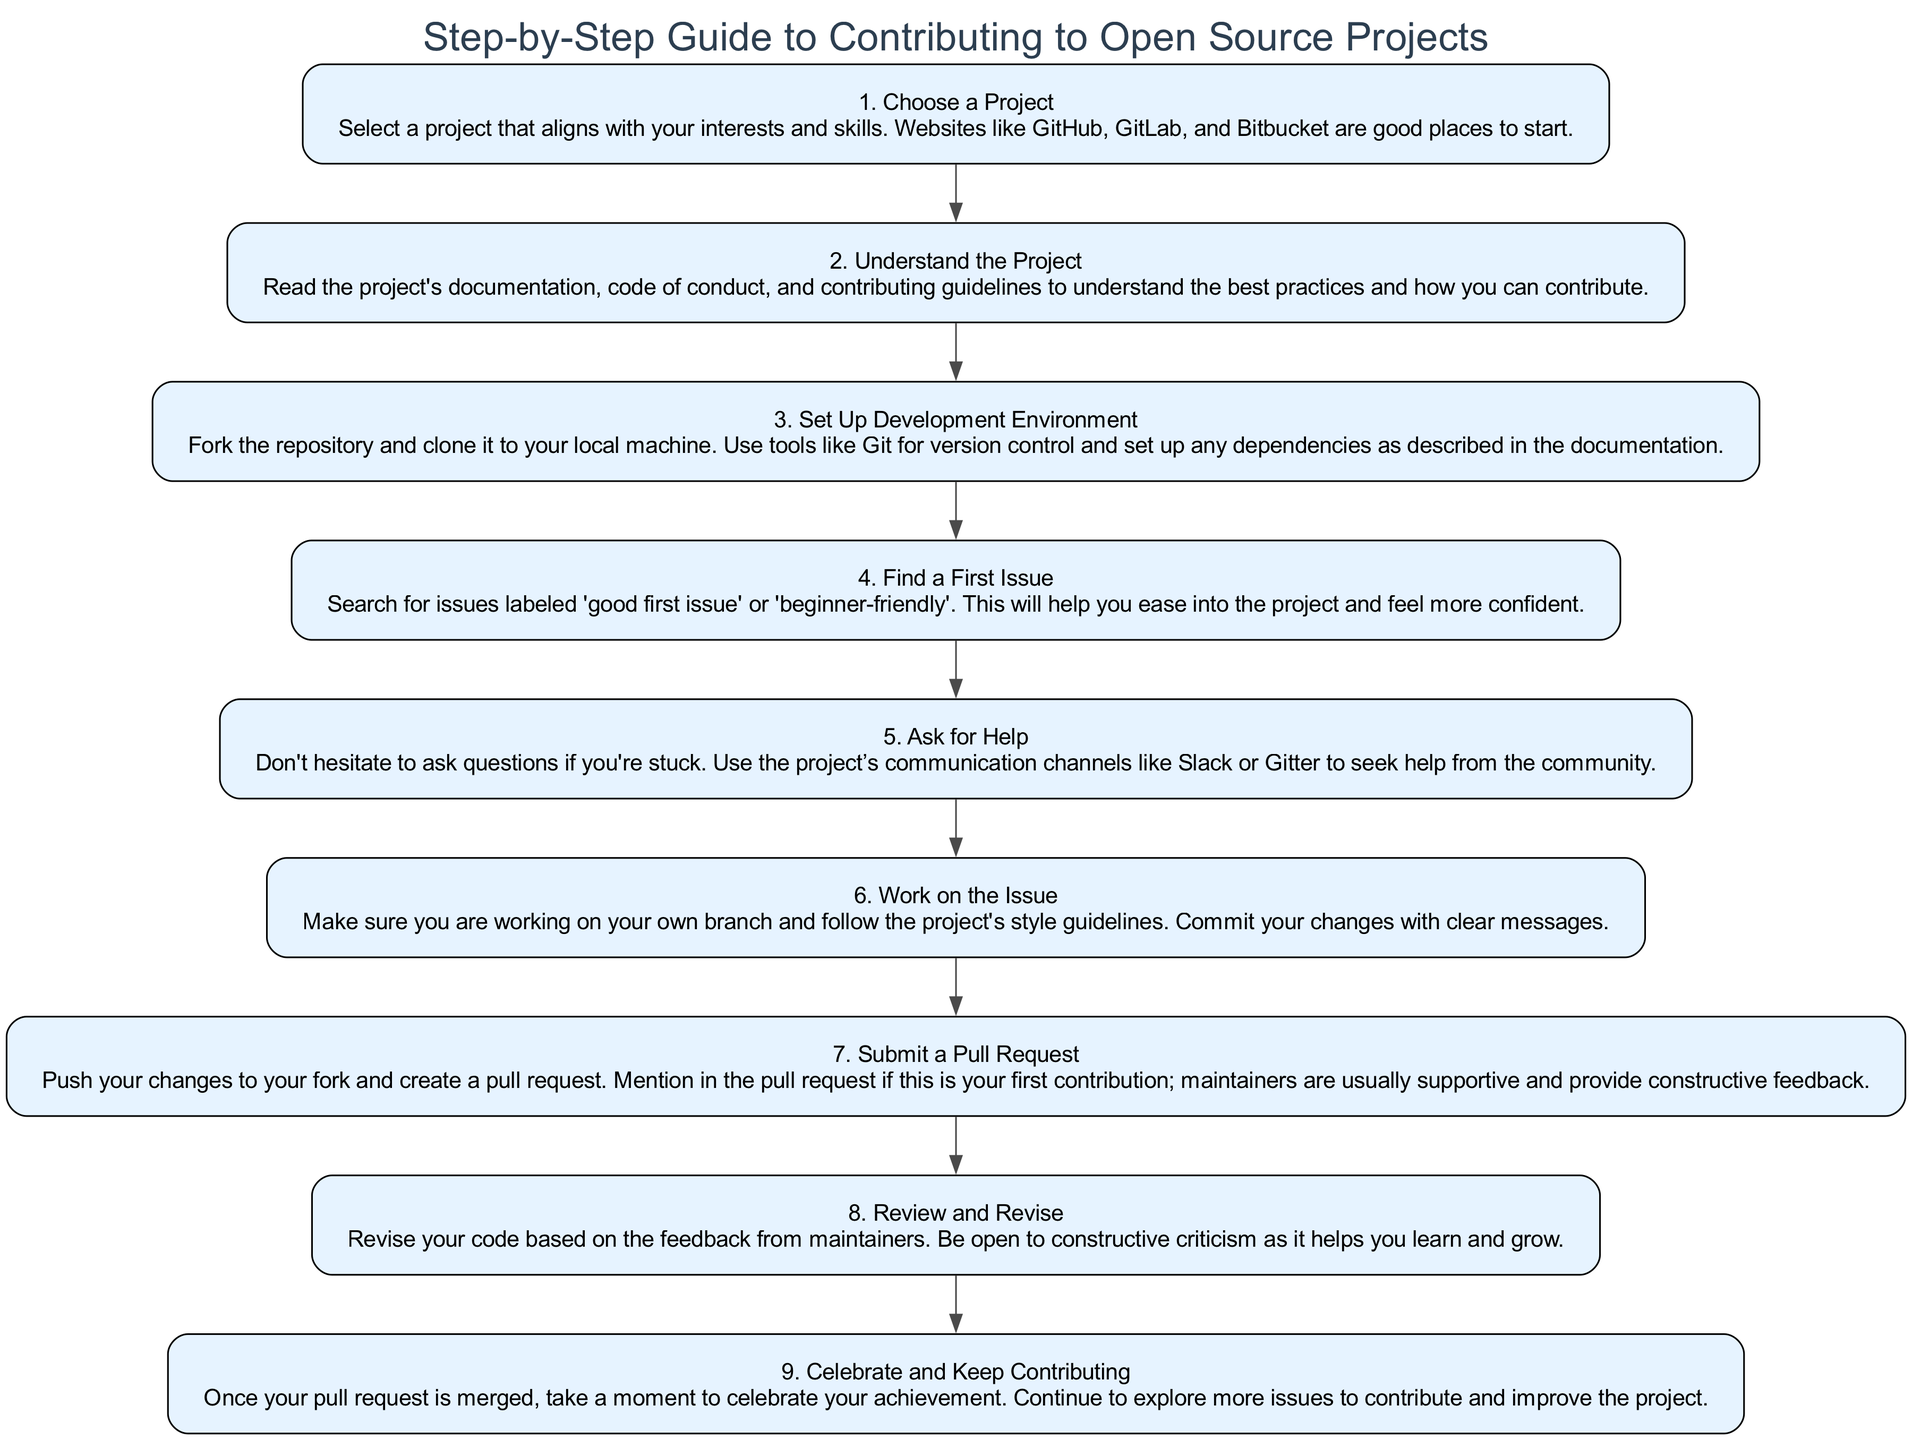What is the first step in the diagram? The first step is labeled "1. Choose a Project," which is indicated as the starting point of the flowchart.
Answer: Choose a Project How many steps are there in total? By counting the number of nodes in the diagram, we find that there are a total of 9 steps listed.
Answer: 9 What is the last step in the diagram? The last step is labeled "9. Celebrate and Keep Contributing," which represents the final action in the flow of instructions.
Answer: Celebrate and Keep Contributing Which step suggests asking for help? Step 5 mentions "Ask for Help," indicating that seeking assistance is encouraged there if someone encounters difficulties.
Answer: Ask for Help What is the relationship between step 3 and step 4? Step 3, "Set Up Development Environment," leads to step 4, "Find a First Issue," indicating a sequential flow where the setup must be completed before finding issues to work on.
Answer: sequential What guarantees support from maintainers during the process? The diagram mentions that when submitting the pull request, you should mention it is your first contribution, which indicates that maintainers are usually supportive and help with constructive feedback.
Answer: mentioning first contribution Which step follows "Work on the Issue"? The step that follows "Work on the Issue" (step 6) is "Submit a Pull Request" (step 7), showing the next action to be taken after completing the issue.
Answer: Submit a Pull Request What does step 8 emphasize about receiving feedback? Step 8, titled "Review and Revise," emphasizes being open to constructive criticism, indicating that feedback is a crucial part of the learning process.
Answer: constructive criticism In which step do you suggest searching for beginner-friendly issues? Step 4 suggests searching for issues labeled "good first issue" or "beginner-friendly," making it clear that this is the recommended action for new contributors.
Answer: Find a First Issue 